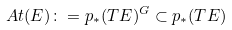<formula> <loc_0><loc_0><loc_500><loc_500>\ A t ( E ) \colon = p _ { * } ( T E ) ^ { G } \subset p _ { * } ( T E )</formula> 